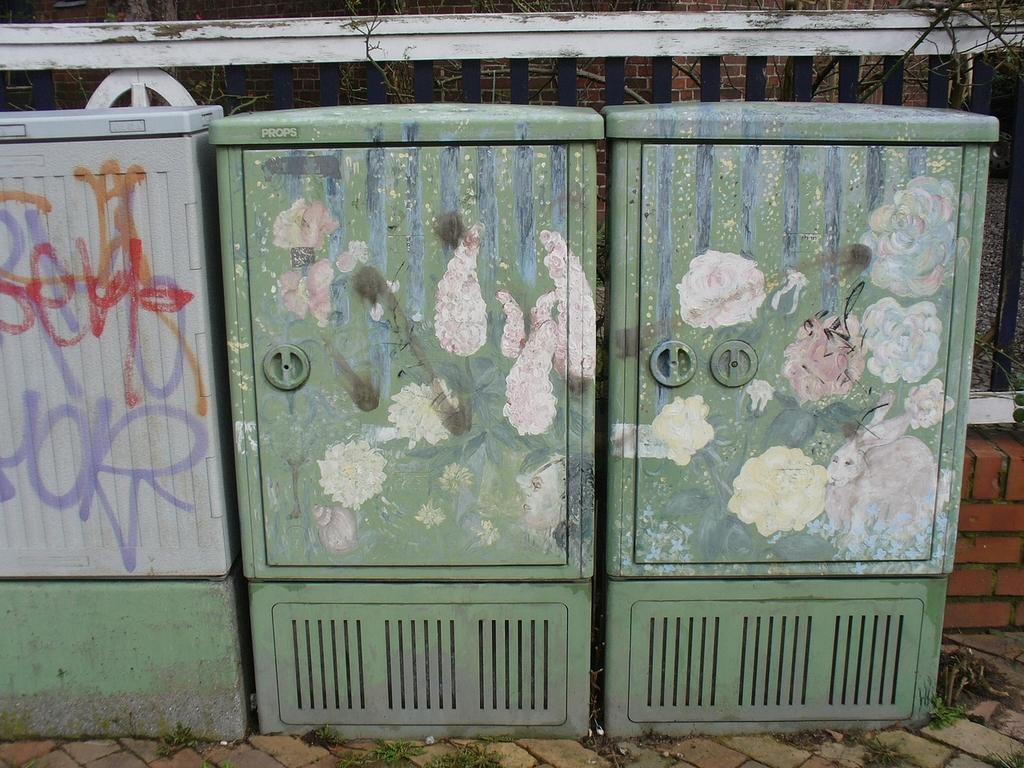What type of containers are present in the image? There are bins in the image. What can be seen in the background of the image? There is a fence in the background of the image. What type of ring is the actor wearing in the image? There is no actor or ring present in the image; it only features bins and a fence in the background. 